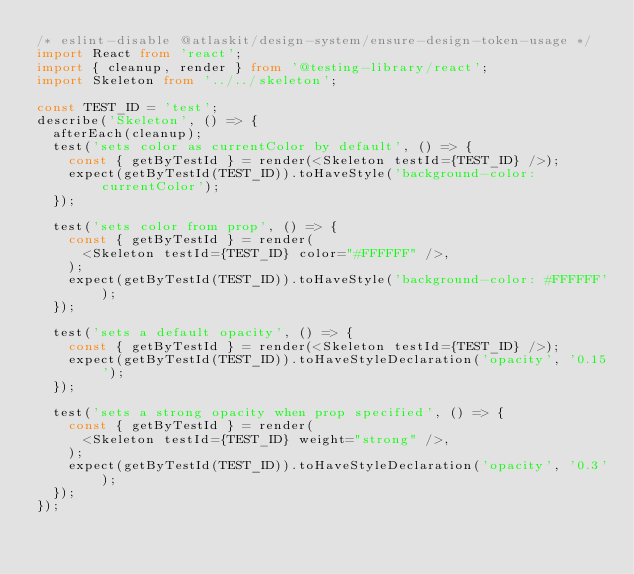<code> <loc_0><loc_0><loc_500><loc_500><_TypeScript_>/* eslint-disable @atlaskit/design-system/ensure-design-token-usage */
import React from 'react';
import { cleanup, render } from '@testing-library/react';
import Skeleton from '../../skeleton';

const TEST_ID = 'test';
describe('Skeleton', () => {
  afterEach(cleanup);
  test('sets color as currentColor by default', () => {
    const { getByTestId } = render(<Skeleton testId={TEST_ID} />);
    expect(getByTestId(TEST_ID)).toHaveStyle('background-color: currentColor');
  });

  test('sets color from prop', () => {
    const { getByTestId } = render(
      <Skeleton testId={TEST_ID} color="#FFFFFF" />,
    );
    expect(getByTestId(TEST_ID)).toHaveStyle('background-color: #FFFFFF');
  });

  test('sets a default opacity', () => {
    const { getByTestId } = render(<Skeleton testId={TEST_ID} />);
    expect(getByTestId(TEST_ID)).toHaveStyleDeclaration('opacity', '0.15');
  });

  test('sets a strong opacity when prop specified', () => {
    const { getByTestId } = render(
      <Skeleton testId={TEST_ID} weight="strong" />,
    );
    expect(getByTestId(TEST_ID)).toHaveStyleDeclaration('opacity', '0.3');
  });
});
</code> 